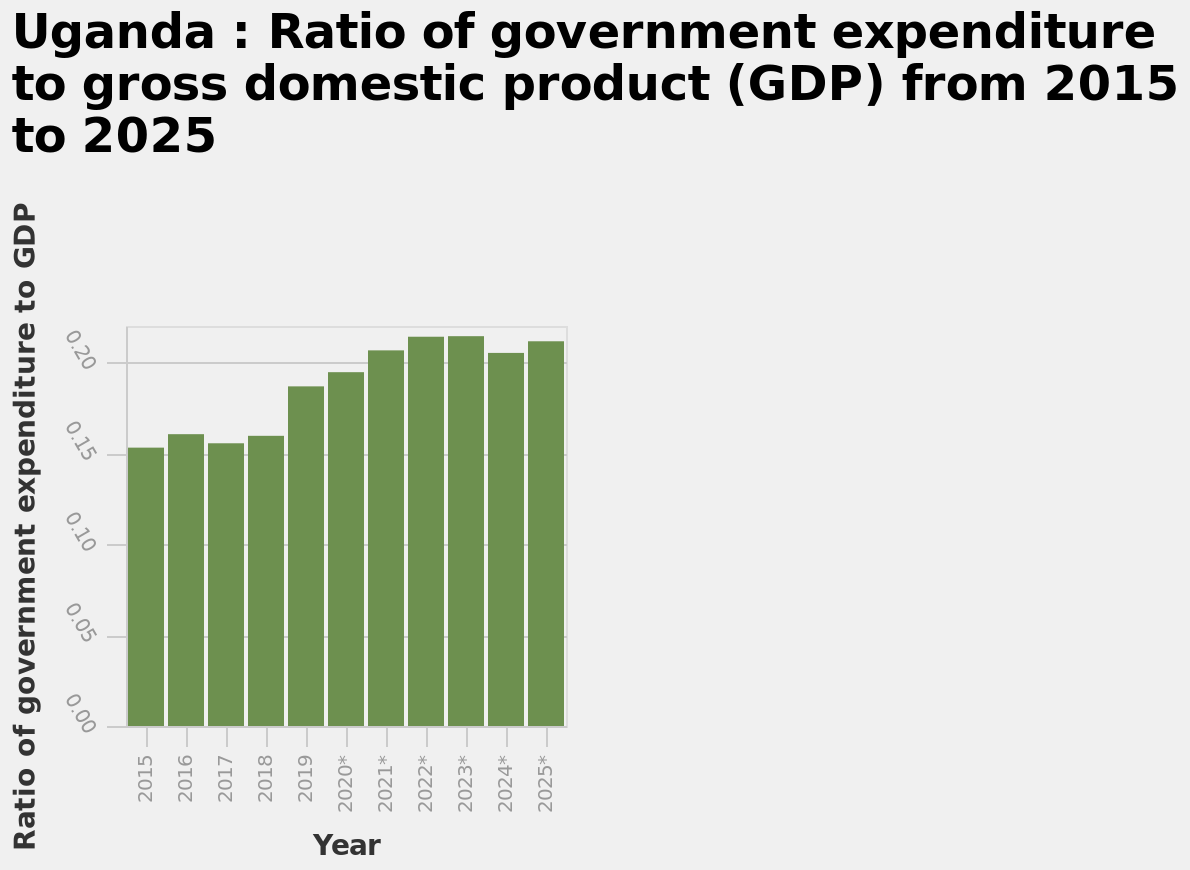<image>
Offer a thorough analysis of the image. The bar chart shows an increase in the ratio between 2015 to 2025. From 2015-2018, spending held steady at just over 0.15.  In 2019, the ratio increased to 0.19, and continued to increase above 0.20 until 2022. 2022 and 2023 held level, with a small decrease in 2024 (but remaining above 0.20). 2025 indicates a return to the ratio seen in 2022 and 2023. What is the title of the bar diagram?  The bar diagram is titled "Uganda: Ratio of government expenditure to gross domestic product (GDP) from 2015 to 2025". Describe the following image in detail Here a bar diagram is titled Uganda : Ratio of government expenditure to gross domestic product (GDP) from 2015 to 2025. A linear scale of range 0.00 to 0.20 can be seen along the y-axis, labeled Ratio of government expenditure to GDP. The x-axis measures Year. What was the ratio of spending in 2025 compared to the ratio in 2015-2018? The ratio of spending in 2025 was the same as the ratio seen in 2022 and 2023. 